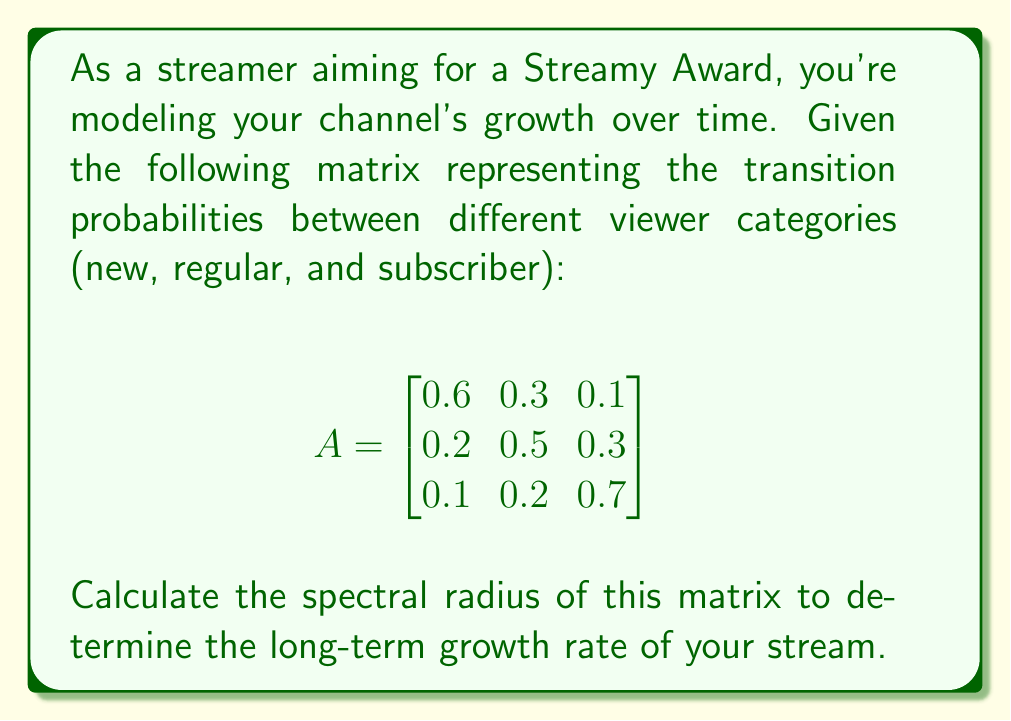Could you help me with this problem? To calculate the spectral radius of matrix A, we need to follow these steps:

1. Find the characteristic equation:
   $det(A - \lambda I) = 0$

2. Expand the determinant:
   $$\begin{vmatrix}
   0.6 - \lambda & 0.3 & 0.1 \\
   0.2 & 0.5 - \lambda & 0.3 \\
   0.1 & 0.2 & 0.7 - \lambda
   \end{vmatrix} = 0$$

3. Calculate the determinant:
   $(0.6 - \lambda)[(0.5 - \lambda)(0.7 - \lambda) - 0.06] - 0.3[0.2(0.7 - \lambda) - 0.03] + 0.1[0.2(0.5 - \lambda) - 0.06] = 0$

4. Simplify:
   $-\lambda^3 + 1.8\lambda^2 - 0.83\lambda + 0.112 = 0$

5. Solve the cubic equation. The roots are the eigenvalues of A.
   Using a numerical method or a cubic equation solver, we find:
   $\lambda_1 \approx 1.0392$
   $\lambda_2 \approx 0.4804$
   $\lambda_3 \approx 0.2804$

6. The spectral radius is the largest absolute value among the eigenvalues:
   $\rho(A) = \max(|\lambda_1|, |\lambda_2|, |\lambda_3|) = |\lambda_1| \approx 1.0392$
Answer: $1.0392$ 